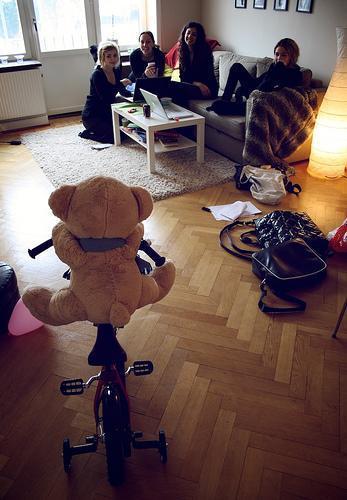How many handbags are in the photo?
Give a very brief answer. 2. How many people can be seen?
Give a very brief answer. 3. 